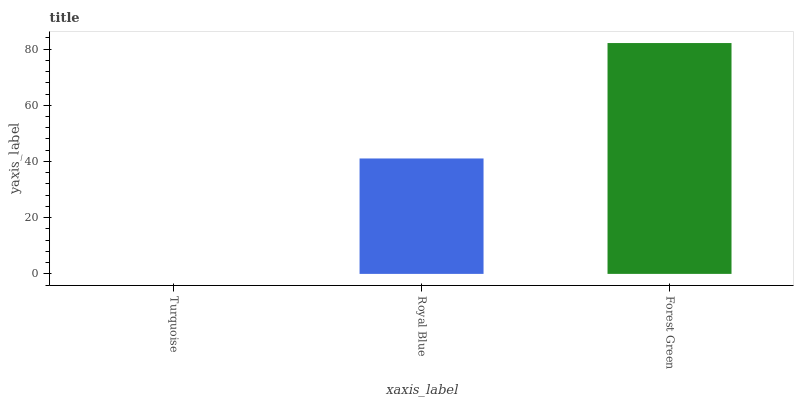Is Turquoise the minimum?
Answer yes or no. Yes. Is Forest Green the maximum?
Answer yes or no. Yes. Is Royal Blue the minimum?
Answer yes or no. No. Is Royal Blue the maximum?
Answer yes or no. No. Is Royal Blue greater than Turquoise?
Answer yes or no. Yes. Is Turquoise less than Royal Blue?
Answer yes or no. Yes. Is Turquoise greater than Royal Blue?
Answer yes or no. No. Is Royal Blue less than Turquoise?
Answer yes or no. No. Is Royal Blue the high median?
Answer yes or no. Yes. Is Royal Blue the low median?
Answer yes or no. Yes. Is Turquoise the high median?
Answer yes or no. No. Is Turquoise the low median?
Answer yes or no. No. 